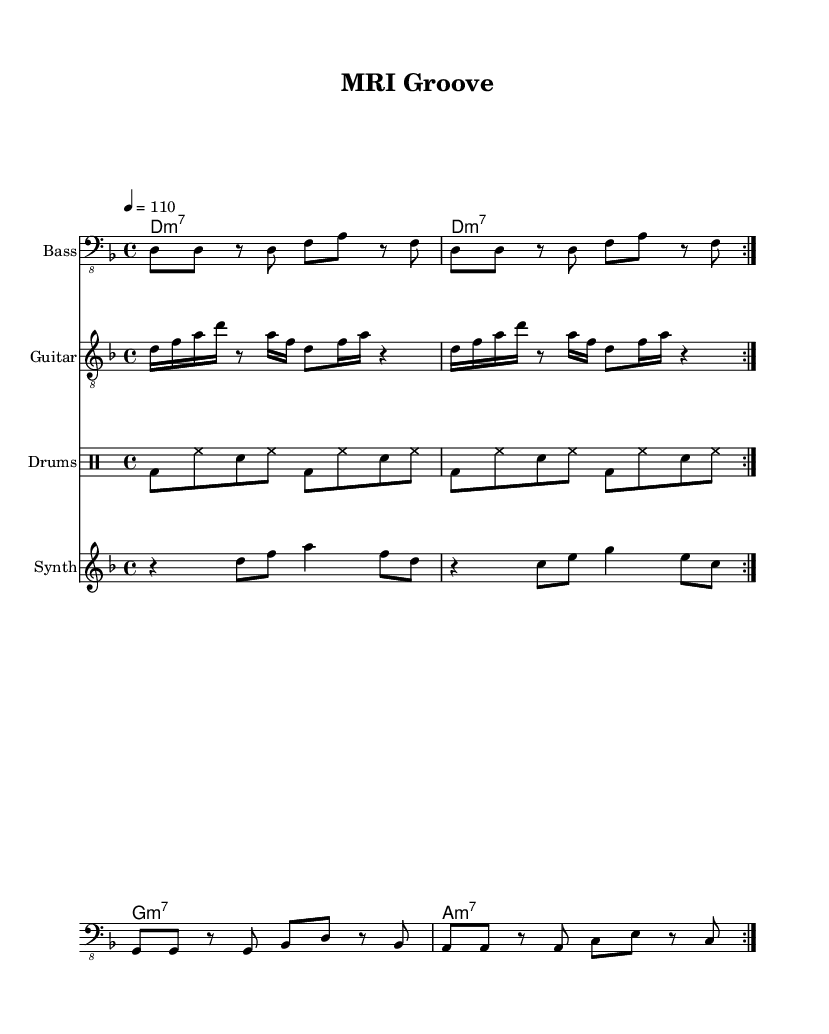What is the key signature of this music? The key signature shows one flat, which indicates that the music is in D minor.
Answer: D minor What is the time signature used in this piece? The time signature indicated at the beginning of the score is 4/4, meaning there are four beats in each measure.
Answer: 4/4 What is the tempo marking for this piece? The tempo marking is indicated with "4 = 110," meaning that there are 110 beats per minute at the quarter note.
Answer: 110 How many repetitions are indicated for the bass line? The bass line is marked with "repeat volta 2," meaning that this section is to be played twice as suggested by the markings.
Answer: 2 What is the first chord in the chord progression? The chord at the start of the sequence is D minor 7, as indicated by the chord symbol "d:m7."
Answer: D minor 7 Which instrument plays the synth melody? The synth melody is notated in the staff specifically designated for the "Synth," clearly indicating which instrument plays this part.
Answer: Synth Why is the drum pattern important in this funk piece? The drum pattern establishes the groove characteristic of funk music, with a strong backbeat provided by the bass drum and snare, enhancing the overall rhythmic drive.
Answer: Groove 